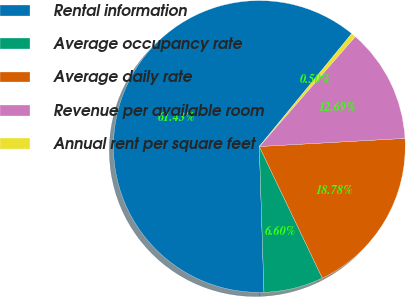Convert chart to OTSL. <chart><loc_0><loc_0><loc_500><loc_500><pie_chart><fcel>Rental information<fcel>Average occupancy rate<fcel>Average daily rate<fcel>Revenue per available room<fcel>Annual rent per square feet<nl><fcel>61.43%<fcel>6.6%<fcel>18.78%<fcel>12.69%<fcel>0.5%<nl></chart> 